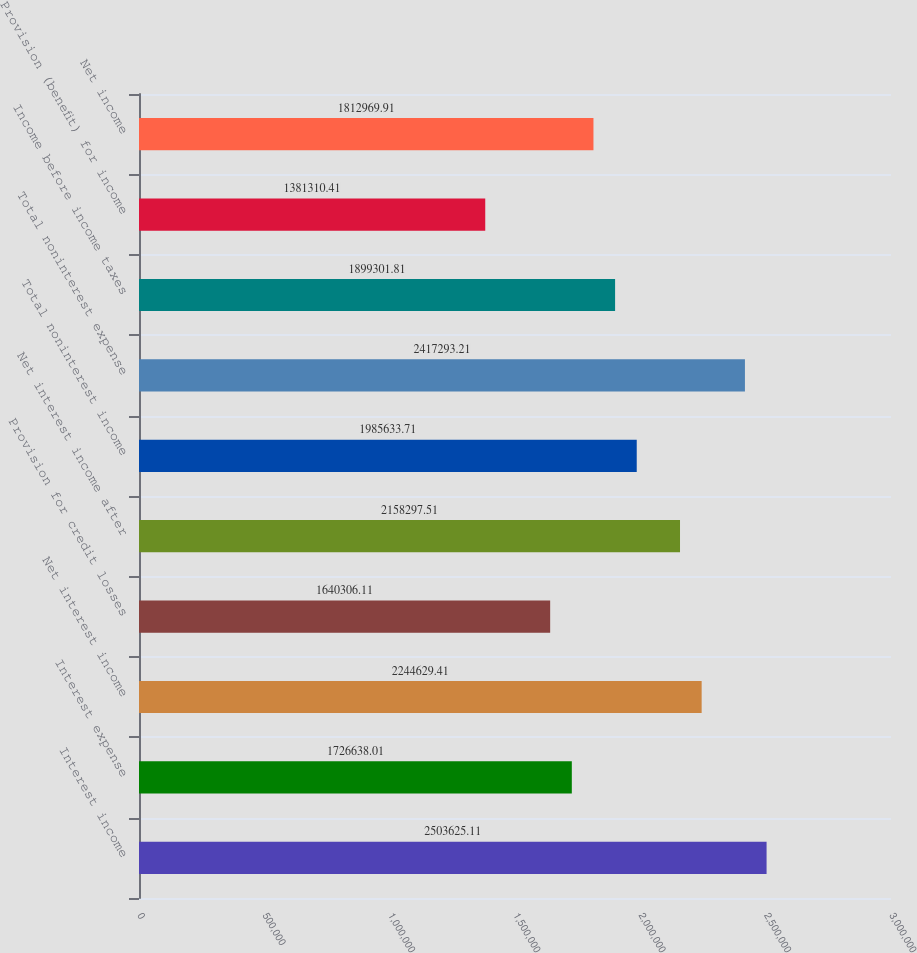Convert chart. <chart><loc_0><loc_0><loc_500><loc_500><bar_chart><fcel>Interest income<fcel>Interest expense<fcel>Net interest income<fcel>Provision for credit losses<fcel>Net interest income after<fcel>Total noninterest income<fcel>Total noninterest expense<fcel>Income before income taxes<fcel>Provision (benefit) for income<fcel>Net income<nl><fcel>2.50363e+06<fcel>1.72664e+06<fcel>2.24463e+06<fcel>1.64031e+06<fcel>2.1583e+06<fcel>1.98563e+06<fcel>2.41729e+06<fcel>1.8993e+06<fcel>1.38131e+06<fcel>1.81297e+06<nl></chart> 